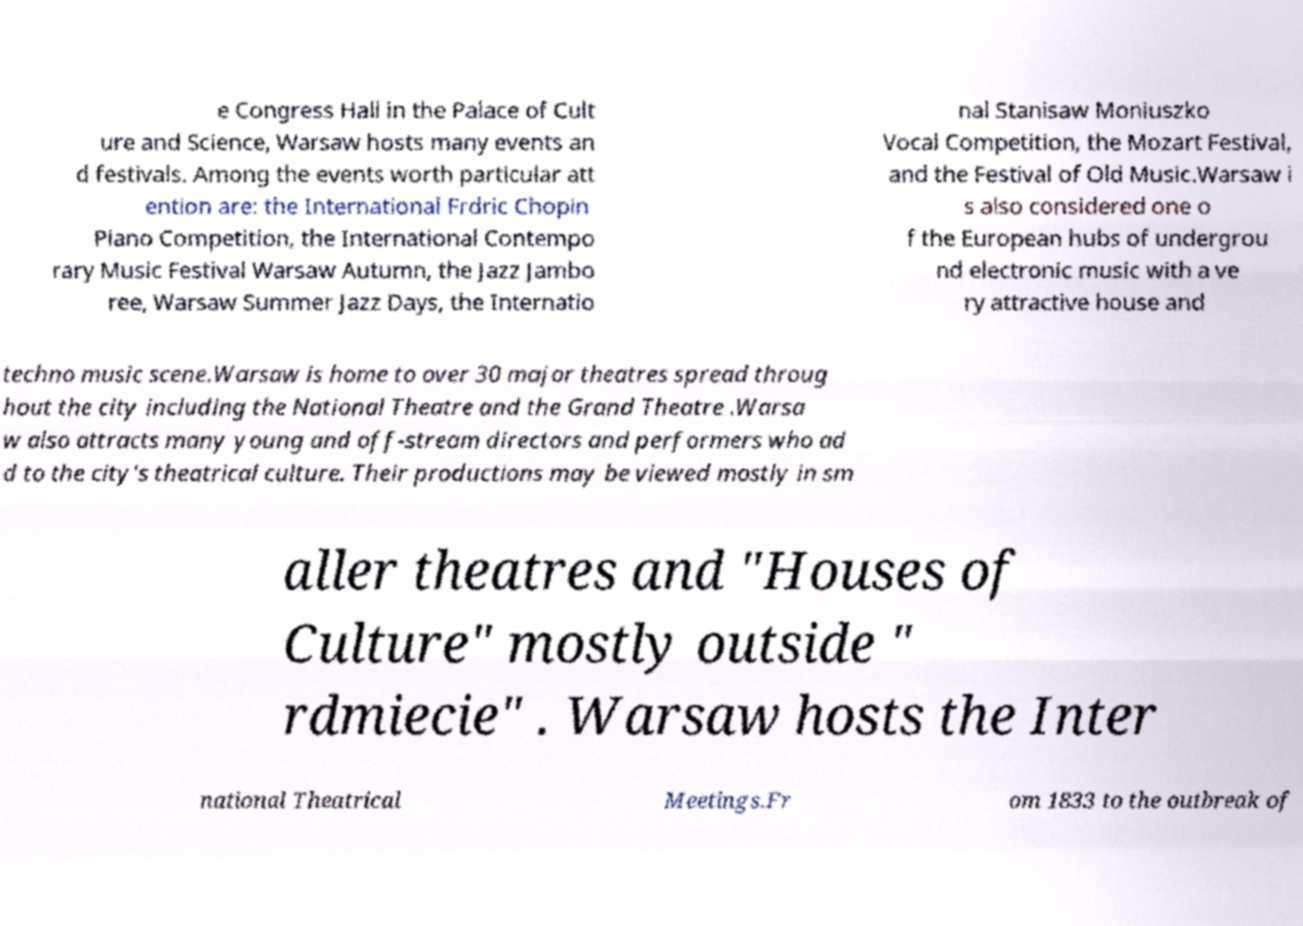I need the written content from this picture converted into text. Can you do that? e Congress Hall in the Palace of Cult ure and Science, Warsaw hosts many events an d festivals. Among the events worth particular att ention are: the International Frdric Chopin Piano Competition, the International Contempo rary Music Festival Warsaw Autumn, the Jazz Jambo ree, Warsaw Summer Jazz Days, the Internatio nal Stanisaw Moniuszko Vocal Competition, the Mozart Festival, and the Festival of Old Music.Warsaw i s also considered one o f the European hubs of undergrou nd electronic music with a ve ry attractive house and techno music scene.Warsaw is home to over 30 major theatres spread throug hout the city including the National Theatre and the Grand Theatre .Warsa w also attracts many young and off-stream directors and performers who ad d to the city's theatrical culture. Their productions may be viewed mostly in sm aller theatres and "Houses of Culture" mostly outside " rdmiecie" . Warsaw hosts the Inter national Theatrical Meetings.Fr om 1833 to the outbreak of 